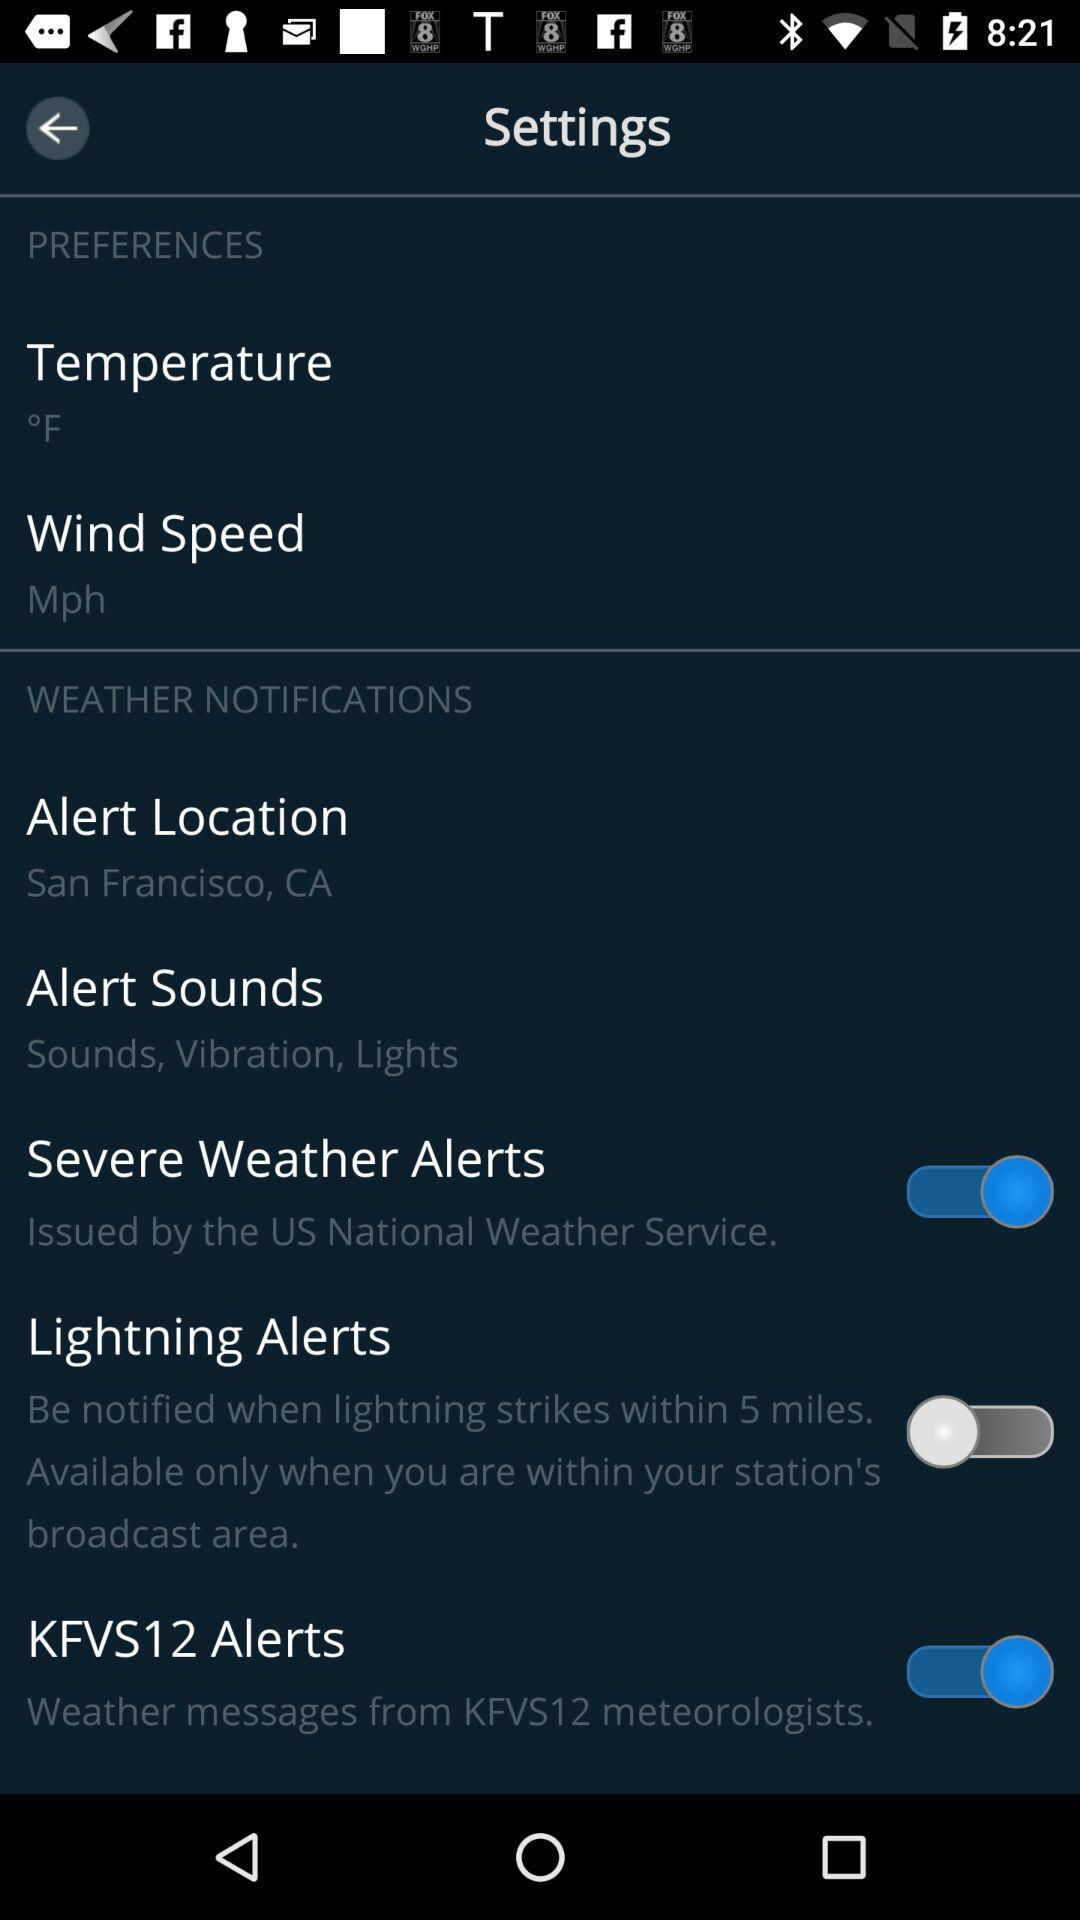What is the location? The location is San Francisco, CA. 